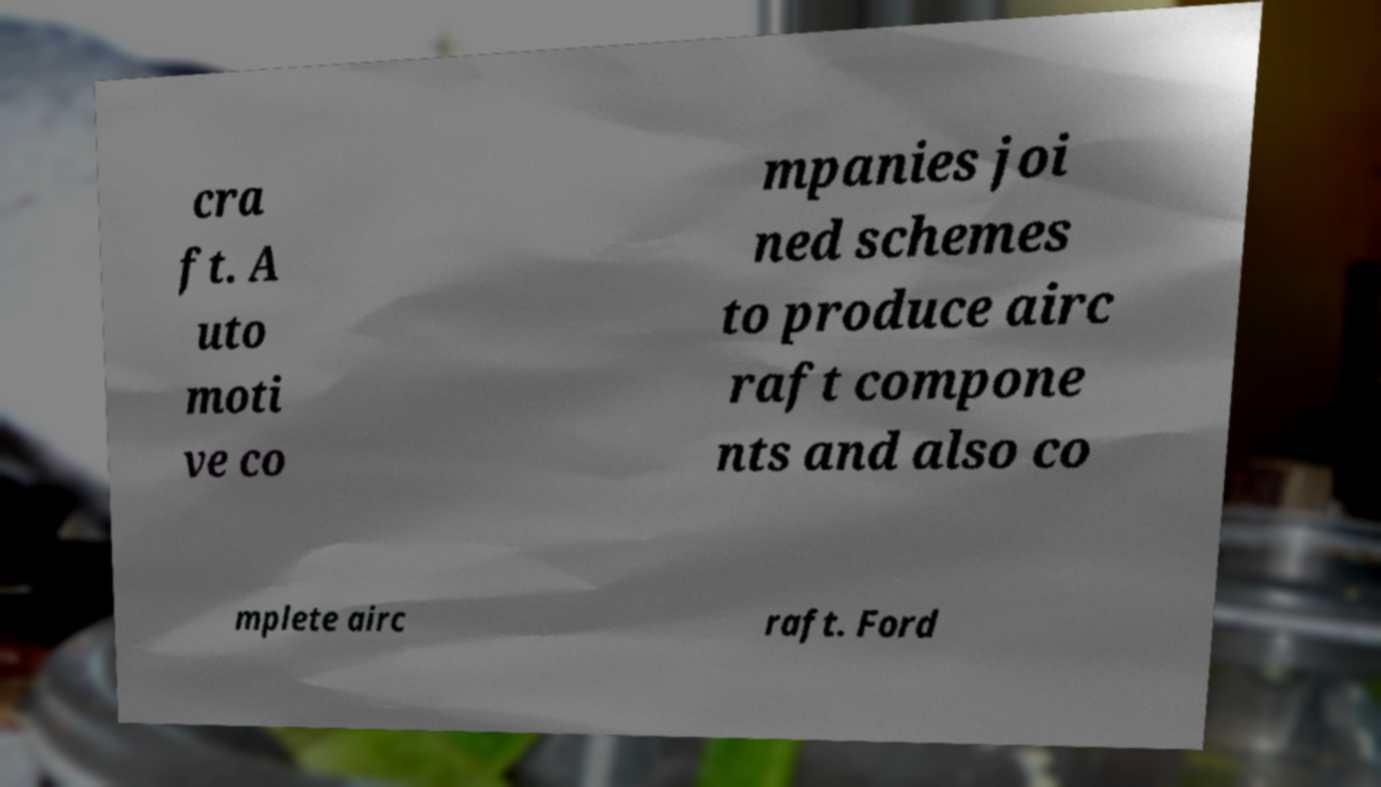I need the written content from this picture converted into text. Can you do that? cra ft. A uto moti ve co mpanies joi ned schemes to produce airc raft compone nts and also co mplete airc raft. Ford 